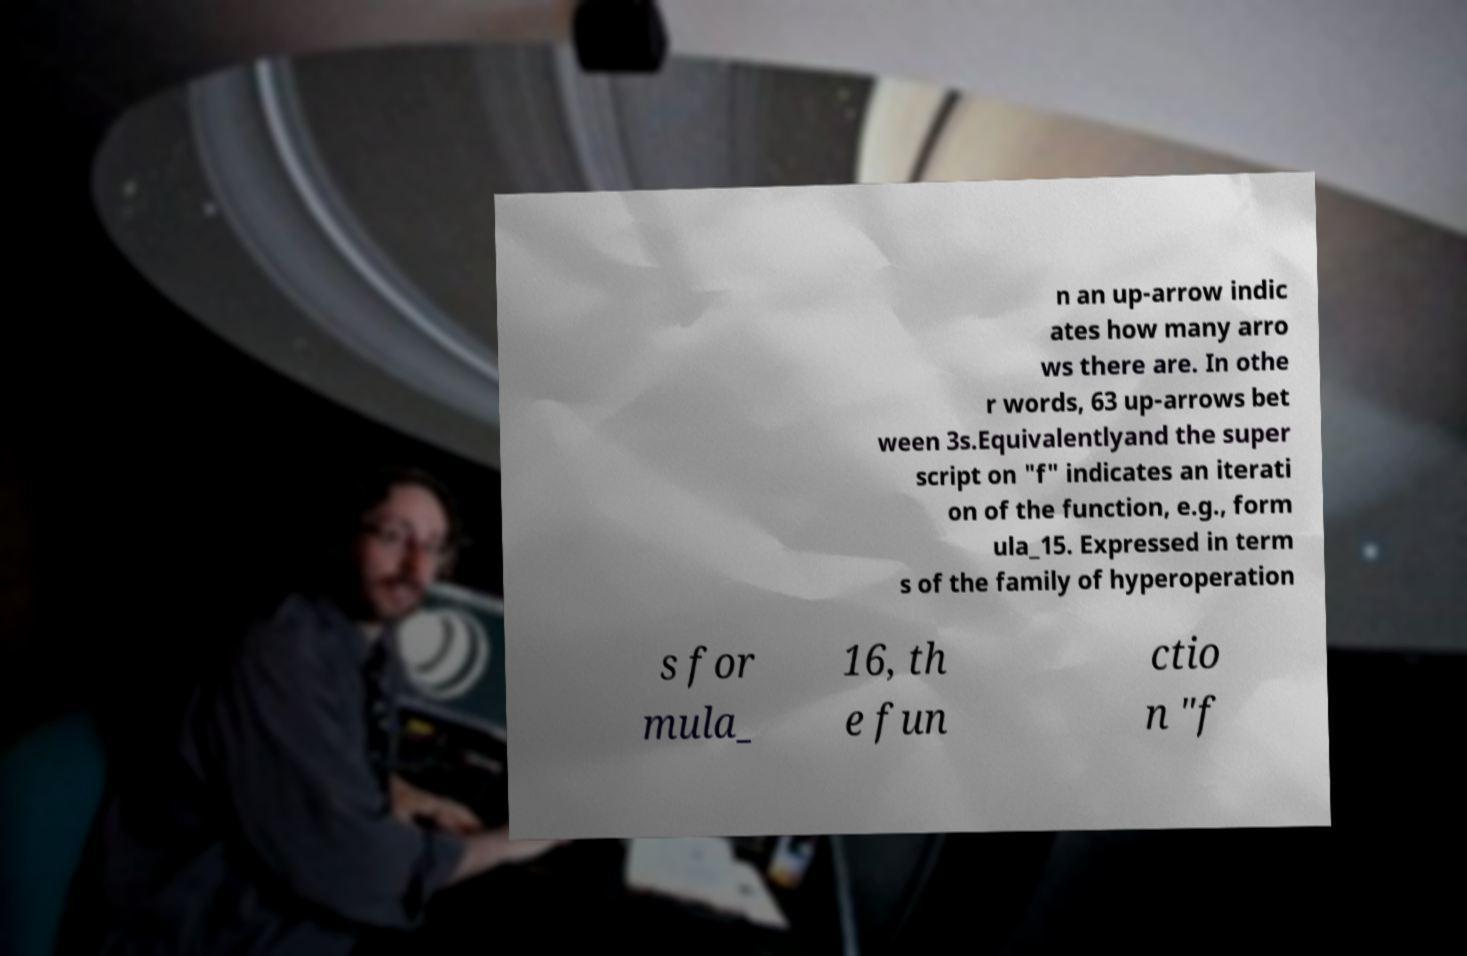Could you extract and type out the text from this image? n an up-arrow indic ates how many arro ws there are. In othe r words, 63 up-arrows bet ween 3s.Equivalentlyand the super script on "f" indicates an iterati on of the function, e.g., form ula_15. Expressed in term s of the family of hyperoperation s for mula_ 16, th e fun ctio n "f 